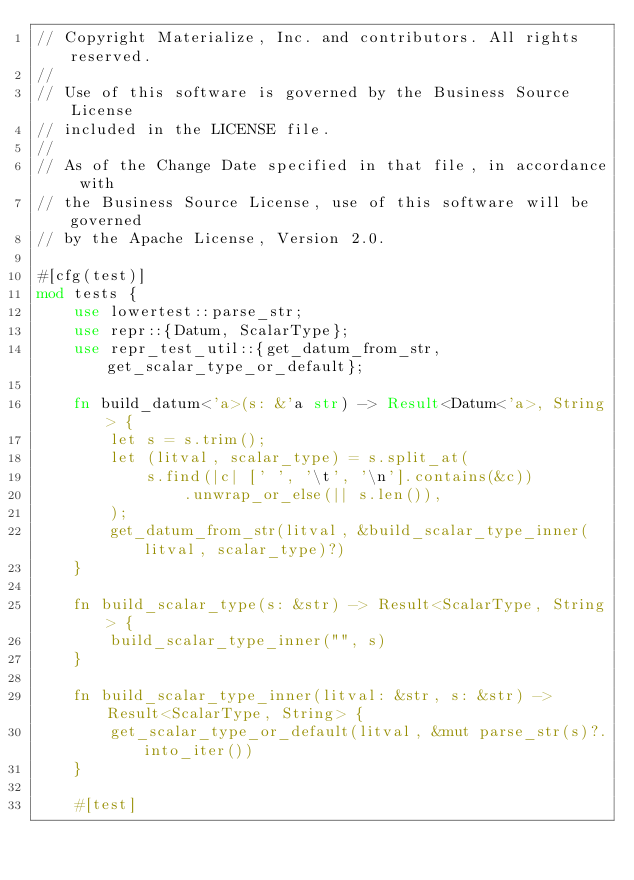Convert code to text. <code><loc_0><loc_0><loc_500><loc_500><_Rust_>// Copyright Materialize, Inc. and contributors. All rights reserved.
//
// Use of this software is governed by the Business Source License
// included in the LICENSE file.
//
// As of the Change Date specified in that file, in accordance with
// the Business Source License, use of this software will be governed
// by the Apache License, Version 2.0.

#[cfg(test)]
mod tests {
    use lowertest::parse_str;
    use repr::{Datum, ScalarType};
    use repr_test_util::{get_datum_from_str, get_scalar_type_or_default};

    fn build_datum<'a>(s: &'a str) -> Result<Datum<'a>, String> {
        let s = s.trim();
        let (litval, scalar_type) = s.split_at(
            s.find(|c| [' ', '\t', '\n'].contains(&c))
                .unwrap_or_else(|| s.len()),
        );
        get_datum_from_str(litval, &build_scalar_type_inner(litval, scalar_type)?)
    }

    fn build_scalar_type(s: &str) -> Result<ScalarType, String> {
        build_scalar_type_inner("", s)
    }

    fn build_scalar_type_inner(litval: &str, s: &str) -> Result<ScalarType, String> {
        get_scalar_type_or_default(litval, &mut parse_str(s)?.into_iter())
    }

    #[test]</code> 